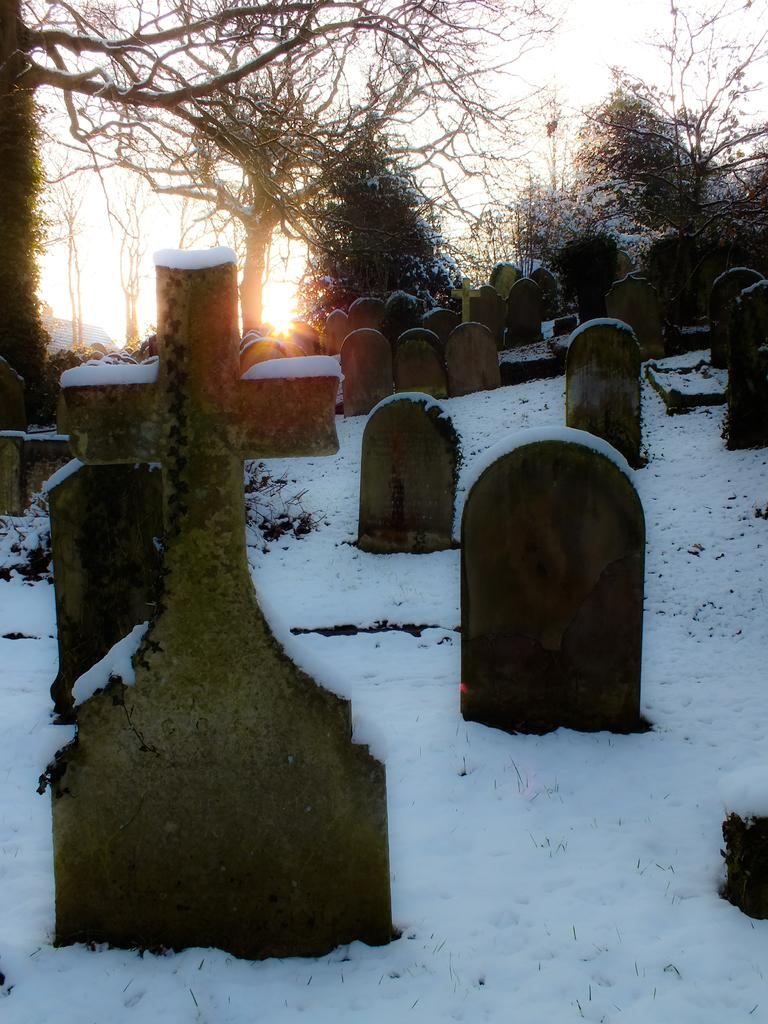What type of objects can be seen in the image? There are memorial stones in the image. What other elements are present in the image? There are trees and the sky is visible in the image. How is the land depicted in the image? The land is covered with snow. Can you tell me what type of store is located near the memorial stones in the image? There is no store present in the image; it features memorial stones, trees, and a snow-covered landscape. 